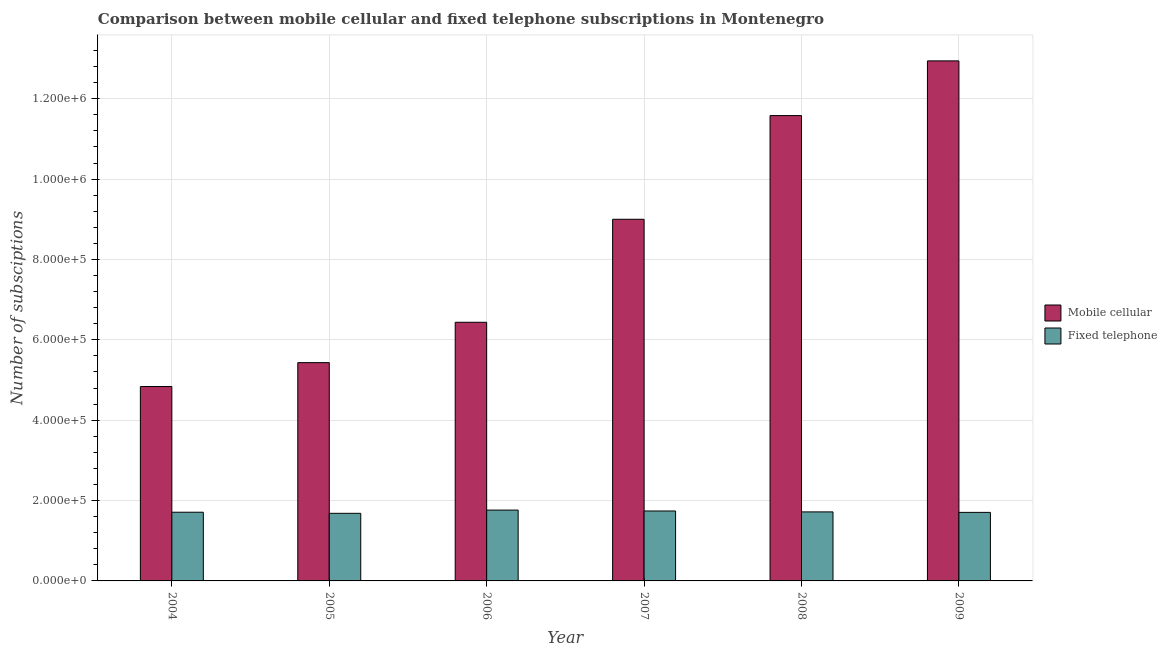How many different coloured bars are there?
Your answer should be compact. 2. Are the number of bars per tick equal to the number of legend labels?
Offer a very short reply. Yes. Are the number of bars on each tick of the X-axis equal?
Provide a succinct answer. Yes. How many bars are there on the 4th tick from the left?
Make the answer very short. 2. How many bars are there on the 3rd tick from the right?
Your answer should be very brief. 2. In how many cases, is the number of bars for a given year not equal to the number of legend labels?
Keep it short and to the point. 0. What is the number of mobile cellular subscriptions in 2006?
Offer a terse response. 6.44e+05. Across all years, what is the maximum number of fixed telephone subscriptions?
Make the answer very short. 1.76e+05. Across all years, what is the minimum number of fixed telephone subscriptions?
Provide a short and direct response. 1.68e+05. In which year was the number of fixed telephone subscriptions minimum?
Your answer should be very brief. 2005. What is the total number of fixed telephone subscriptions in the graph?
Keep it short and to the point. 1.03e+06. What is the difference between the number of fixed telephone subscriptions in 2006 and that in 2008?
Provide a short and direct response. 4540. What is the difference between the number of mobile cellular subscriptions in 2005 and the number of fixed telephone subscriptions in 2009?
Your response must be concise. -7.51e+05. What is the average number of mobile cellular subscriptions per year?
Ensure brevity in your answer.  8.37e+05. In the year 2005, what is the difference between the number of mobile cellular subscriptions and number of fixed telephone subscriptions?
Your answer should be very brief. 0. In how many years, is the number of mobile cellular subscriptions greater than 640000?
Give a very brief answer. 4. What is the ratio of the number of fixed telephone subscriptions in 2005 to that in 2007?
Offer a very short reply. 0.97. What is the difference between the highest and the second highest number of fixed telephone subscriptions?
Ensure brevity in your answer.  2243. What is the difference between the highest and the lowest number of mobile cellular subscriptions?
Your response must be concise. 8.10e+05. What does the 1st bar from the left in 2007 represents?
Your answer should be compact. Mobile cellular. What does the 2nd bar from the right in 2006 represents?
Provide a short and direct response. Mobile cellular. How many years are there in the graph?
Keep it short and to the point. 6. Are the values on the major ticks of Y-axis written in scientific E-notation?
Your answer should be very brief. Yes. Does the graph contain any zero values?
Make the answer very short. No. Where does the legend appear in the graph?
Ensure brevity in your answer.  Center right. How are the legend labels stacked?
Offer a terse response. Vertical. What is the title of the graph?
Provide a succinct answer. Comparison between mobile cellular and fixed telephone subscriptions in Montenegro. Does "US$" appear as one of the legend labels in the graph?
Offer a very short reply. No. What is the label or title of the Y-axis?
Keep it short and to the point. Number of subsciptions. What is the Number of subsciptions of Mobile cellular in 2004?
Your answer should be very brief. 4.84e+05. What is the Number of subsciptions in Fixed telephone in 2004?
Make the answer very short. 1.71e+05. What is the Number of subsciptions in Mobile cellular in 2005?
Keep it short and to the point. 5.43e+05. What is the Number of subsciptions of Fixed telephone in 2005?
Make the answer very short. 1.68e+05. What is the Number of subsciptions of Mobile cellular in 2006?
Provide a succinct answer. 6.44e+05. What is the Number of subsciptions of Fixed telephone in 2006?
Your answer should be very brief. 1.76e+05. What is the Number of subsciptions of Mobile cellular in 2007?
Provide a short and direct response. 9.00e+05. What is the Number of subsciptions of Fixed telephone in 2007?
Keep it short and to the point. 1.74e+05. What is the Number of subsciptions of Mobile cellular in 2008?
Ensure brevity in your answer.  1.16e+06. What is the Number of subsciptions of Fixed telephone in 2008?
Provide a short and direct response. 1.72e+05. What is the Number of subsciptions of Mobile cellular in 2009?
Ensure brevity in your answer.  1.29e+06. What is the Number of subsciptions in Fixed telephone in 2009?
Your answer should be compact. 1.71e+05. Across all years, what is the maximum Number of subsciptions of Mobile cellular?
Your answer should be very brief. 1.29e+06. Across all years, what is the maximum Number of subsciptions in Fixed telephone?
Provide a short and direct response. 1.76e+05. Across all years, what is the minimum Number of subsciptions in Mobile cellular?
Your answer should be very brief. 4.84e+05. Across all years, what is the minimum Number of subsciptions in Fixed telephone?
Provide a short and direct response. 1.68e+05. What is the total Number of subsciptions of Mobile cellular in the graph?
Ensure brevity in your answer.  5.02e+06. What is the total Number of subsciptions of Fixed telephone in the graph?
Your answer should be compact. 1.03e+06. What is the difference between the Number of subsciptions of Mobile cellular in 2004 and that in 2005?
Your response must be concise. -5.95e+04. What is the difference between the Number of subsciptions of Fixed telephone in 2004 and that in 2005?
Keep it short and to the point. 2700. What is the difference between the Number of subsciptions in Mobile cellular in 2004 and that in 2006?
Ensure brevity in your answer.  -1.60e+05. What is the difference between the Number of subsciptions in Fixed telephone in 2004 and that in 2006?
Your response must be concise. -5356. What is the difference between the Number of subsciptions in Mobile cellular in 2004 and that in 2007?
Your answer should be compact. -4.16e+05. What is the difference between the Number of subsciptions of Fixed telephone in 2004 and that in 2007?
Provide a short and direct response. -3113. What is the difference between the Number of subsciptions in Mobile cellular in 2004 and that in 2008?
Ensure brevity in your answer.  -6.74e+05. What is the difference between the Number of subsciptions of Fixed telephone in 2004 and that in 2008?
Your answer should be very brief. -816. What is the difference between the Number of subsciptions in Mobile cellular in 2004 and that in 2009?
Your answer should be compact. -8.10e+05. What is the difference between the Number of subsciptions in Fixed telephone in 2004 and that in 2009?
Provide a succinct answer. 380. What is the difference between the Number of subsciptions of Mobile cellular in 2005 and that in 2006?
Offer a very short reply. -1.00e+05. What is the difference between the Number of subsciptions of Fixed telephone in 2005 and that in 2006?
Provide a succinct answer. -8056. What is the difference between the Number of subsciptions of Mobile cellular in 2005 and that in 2007?
Provide a short and direct response. -3.57e+05. What is the difference between the Number of subsciptions in Fixed telephone in 2005 and that in 2007?
Your answer should be very brief. -5813. What is the difference between the Number of subsciptions in Mobile cellular in 2005 and that in 2008?
Your answer should be very brief. -6.15e+05. What is the difference between the Number of subsciptions in Fixed telephone in 2005 and that in 2008?
Ensure brevity in your answer.  -3516. What is the difference between the Number of subsciptions in Mobile cellular in 2005 and that in 2009?
Keep it short and to the point. -7.51e+05. What is the difference between the Number of subsciptions of Fixed telephone in 2005 and that in 2009?
Offer a terse response. -2320. What is the difference between the Number of subsciptions of Mobile cellular in 2006 and that in 2007?
Keep it short and to the point. -2.56e+05. What is the difference between the Number of subsciptions of Fixed telephone in 2006 and that in 2007?
Ensure brevity in your answer.  2243. What is the difference between the Number of subsciptions in Mobile cellular in 2006 and that in 2008?
Make the answer very short. -5.14e+05. What is the difference between the Number of subsciptions in Fixed telephone in 2006 and that in 2008?
Offer a very short reply. 4540. What is the difference between the Number of subsciptions in Mobile cellular in 2006 and that in 2009?
Offer a very short reply. -6.50e+05. What is the difference between the Number of subsciptions of Fixed telephone in 2006 and that in 2009?
Ensure brevity in your answer.  5736. What is the difference between the Number of subsciptions of Mobile cellular in 2007 and that in 2008?
Keep it short and to the point. -2.58e+05. What is the difference between the Number of subsciptions of Fixed telephone in 2007 and that in 2008?
Your response must be concise. 2297. What is the difference between the Number of subsciptions of Mobile cellular in 2007 and that in 2009?
Offer a terse response. -3.94e+05. What is the difference between the Number of subsciptions in Fixed telephone in 2007 and that in 2009?
Your response must be concise. 3493. What is the difference between the Number of subsciptions in Mobile cellular in 2008 and that in 2009?
Offer a very short reply. -1.36e+05. What is the difference between the Number of subsciptions of Fixed telephone in 2008 and that in 2009?
Offer a terse response. 1196. What is the difference between the Number of subsciptions of Mobile cellular in 2004 and the Number of subsciptions of Fixed telephone in 2005?
Keep it short and to the point. 3.16e+05. What is the difference between the Number of subsciptions in Mobile cellular in 2004 and the Number of subsciptions in Fixed telephone in 2006?
Give a very brief answer. 3.07e+05. What is the difference between the Number of subsciptions of Mobile cellular in 2004 and the Number of subsciptions of Fixed telephone in 2007?
Provide a short and direct response. 3.10e+05. What is the difference between the Number of subsciptions of Mobile cellular in 2004 and the Number of subsciptions of Fixed telephone in 2008?
Offer a very short reply. 3.12e+05. What is the difference between the Number of subsciptions in Mobile cellular in 2004 and the Number of subsciptions in Fixed telephone in 2009?
Provide a short and direct response. 3.13e+05. What is the difference between the Number of subsciptions of Mobile cellular in 2005 and the Number of subsciptions of Fixed telephone in 2006?
Provide a succinct answer. 3.67e+05. What is the difference between the Number of subsciptions in Mobile cellular in 2005 and the Number of subsciptions in Fixed telephone in 2007?
Give a very brief answer. 3.69e+05. What is the difference between the Number of subsciptions in Mobile cellular in 2005 and the Number of subsciptions in Fixed telephone in 2008?
Give a very brief answer. 3.71e+05. What is the difference between the Number of subsciptions of Mobile cellular in 2005 and the Number of subsciptions of Fixed telephone in 2009?
Ensure brevity in your answer.  3.73e+05. What is the difference between the Number of subsciptions of Mobile cellular in 2006 and the Number of subsciptions of Fixed telephone in 2007?
Ensure brevity in your answer.  4.70e+05. What is the difference between the Number of subsciptions of Mobile cellular in 2006 and the Number of subsciptions of Fixed telephone in 2008?
Make the answer very short. 4.72e+05. What is the difference between the Number of subsciptions in Mobile cellular in 2006 and the Number of subsciptions in Fixed telephone in 2009?
Your answer should be very brief. 4.73e+05. What is the difference between the Number of subsciptions in Mobile cellular in 2007 and the Number of subsciptions in Fixed telephone in 2008?
Your response must be concise. 7.28e+05. What is the difference between the Number of subsciptions of Mobile cellular in 2007 and the Number of subsciptions of Fixed telephone in 2009?
Your answer should be compact. 7.29e+05. What is the difference between the Number of subsciptions of Mobile cellular in 2008 and the Number of subsciptions of Fixed telephone in 2009?
Ensure brevity in your answer.  9.87e+05. What is the average Number of subsciptions of Mobile cellular per year?
Give a very brief answer. 8.37e+05. What is the average Number of subsciptions in Fixed telephone per year?
Offer a terse response. 1.72e+05. In the year 2004, what is the difference between the Number of subsciptions in Mobile cellular and Number of subsciptions in Fixed telephone?
Give a very brief answer. 3.13e+05. In the year 2005, what is the difference between the Number of subsciptions in Mobile cellular and Number of subsciptions in Fixed telephone?
Offer a terse response. 3.75e+05. In the year 2006, what is the difference between the Number of subsciptions of Mobile cellular and Number of subsciptions of Fixed telephone?
Make the answer very short. 4.67e+05. In the year 2007, what is the difference between the Number of subsciptions of Mobile cellular and Number of subsciptions of Fixed telephone?
Your answer should be very brief. 7.26e+05. In the year 2008, what is the difference between the Number of subsciptions in Mobile cellular and Number of subsciptions in Fixed telephone?
Your answer should be very brief. 9.86e+05. In the year 2009, what is the difference between the Number of subsciptions in Mobile cellular and Number of subsciptions in Fixed telephone?
Ensure brevity in your answer.  1.12e+06. What is the ratio of the Number of subsciptions of Mobile cellular in 2004 to that in 2005?
Ensure brevity in your answer.  0.89. What is the ratio of the Number of subsciptions in Fixed telephone in 2004 to that in 2005?
Your answer should be very brief. 1.02. What is the ratio of the Number of subsciptions of Mobile cellular in 2004 to that in 2006?
Offer a very short reply. 0.75. What is the ratio of the Number of subsciptions of Fixed telephone in 2004 to that in 2006?
Your answer should be very brief. 0.97. What is the ratio of the Number of subsciptions in Mobile cellular in 2004 to that in 2007?
Ensure brevity in your answer.  0.54. What is the ratio of the Number of subsciptions in Fixed telephone in 2004 to that in 2007?
Make the answer very short. 0.98. What is the ratio of the Number of subsciptions in Mobile cellular in 2004 to that in 2008?
Keep it short and to the point. 0.42. What is the ratio of the Number of subsciptions of Mobile cellular in 2004 to that in 2009?
Your answer should be compact. 0.37. What is the ratio of the Number of subsciptions of Mobile cellular in 2005 to that in 2006?
Your answer should be very brief. 0.84. What is the ratio of the Number of subsciptions of Fixed telephone in 2005 to that in 2006?
Your answer should be very brief. 0.95. What is the ratio of the Number of subsciptions in Mobile cellular in 2005 to that in 2007?
Your response must be concise. 0.6. What is the ratio of the Number of subsciptions in Fixed telephone in 2005 to that in 2007?
Your answer should be very brief. 0.97. What is the ratio of the Number of subsciptions of Mobile cellular in 2005 to that in 2008?
Provide a succinct answer. 0.47. What is the ratio of the Number of subsciptions in Fixed telephone in 2005 to that in 2008?
Your answer should be very brief. 0.98. What is the ratio of the Number of subsciptions in Mobile cellular in 2005 to that in 2009?
Offer a terse response. 0.42. What is the ratio of the Number of subsciptions in Fixed telephone in 2005 to that in 2009?
Offer a very short reply. 0.99. What is the ratio of the Number of subsciptions of Mobile cellular in 2006 to that in 2007?
Your answer should be very brief. 0.72. What is the ratio of the Number of subsciptions of Fixed telephone in 2006 to that in 2007?
Make the answer very short. 1.01. What is the ratio of the Number of subsciptions in Mobile cellular in 2006 to that in 2008?
Make the answer very short. 0.56. What is the ratio of the Number of subsciptions in Fixed telephone in 2006 to that in 2008?
Your answer should be very brief. 1.03. What is the ratio of the Number of subsciptions of Mobile cellular in 2006 to that in 2009?
Offer a very short reply. 0.5. What is the ratio of the Number of subsciptions in Fixed telephone in 2006 to that in 2009?
Provide a short and direct response. 1.03. What is the ratio of the Number of subsciptions of Mobile cellular in 2007 to that in 2008?
Keep it short and to the point. 0.78. What is the ratio of the Number of subsciptions of Fixed telephone in 2007 to that in 2008?
Keep it short and to the point. 1.01. What is the ratio of the Number of subsciptions in Mobile cellular in 2007 to that in 2009?
Offer a very short reply. 0.7. What is the ratio of the Number of subsciptions in Fixed telephone in 2007 to that in 2009?
Your response must be concise. 1.02. What is the ratio of the Number of subsciptions of Mobile cellular in 2008 to that in 2009?
Offer a very short reply. 0.89. What is the ratio of the Number of subsciptions in Fixed telephone in 2008 to that in 2009?
Keep it short and to the point. 1.01. What is the difference between the highest and the second highest Number of subsciptions in Mobile cellular?
Your response must be concise. 1.36e+05. What is the difference between the highest and the second highest Number of subsciptions in Fixed telephone?
Provide a short and direct response. 2243. What is the difference between the highest and the lowest Number of subsciptions in Mobile cellular?
Offer a terse response. 8.10e+05. What is the difference between the highest and the lowest Number of subsciptions in Fixed telephone?
Make the answer very short. 8056. 